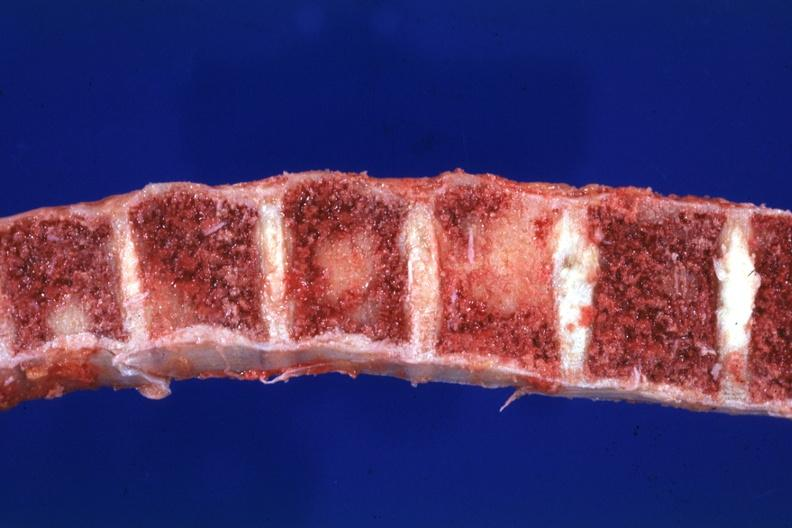does this image show close-up view typical lesions?
Answer the question using a single word or phrase. Yes 